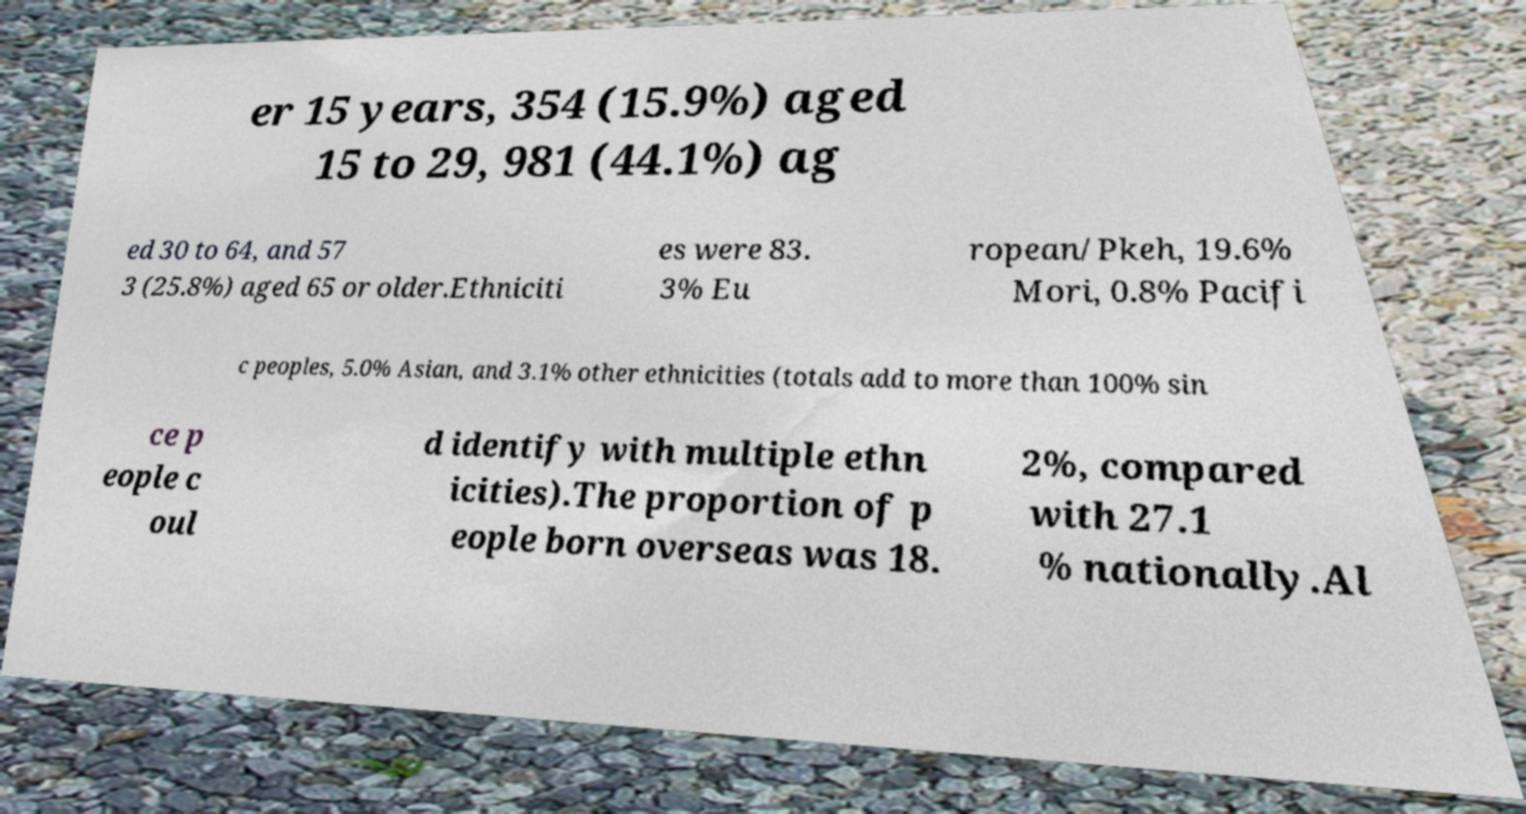For documentation purposes, I need the text within this image transcribed. Could you provide that? er 15 years, 354 (15.9%) aged 15 to 29, 981 (44.1%) ag ed 30 to 64, and 57 3 (25.8%) aged 65 or older.Ethniciti es were 83. 3% Eu ropean/Pkeh, 19.6% Mori, 0.8% Pacifi c peoples, 5.0% Asian, and 3.1% other ethnicities (totals add to more than 100% sin ce p eople c oul d identify with multiple ethn icities).The proportion of p eople born overseas was 18. 2%, compared with 27.1 % nationally.Al 